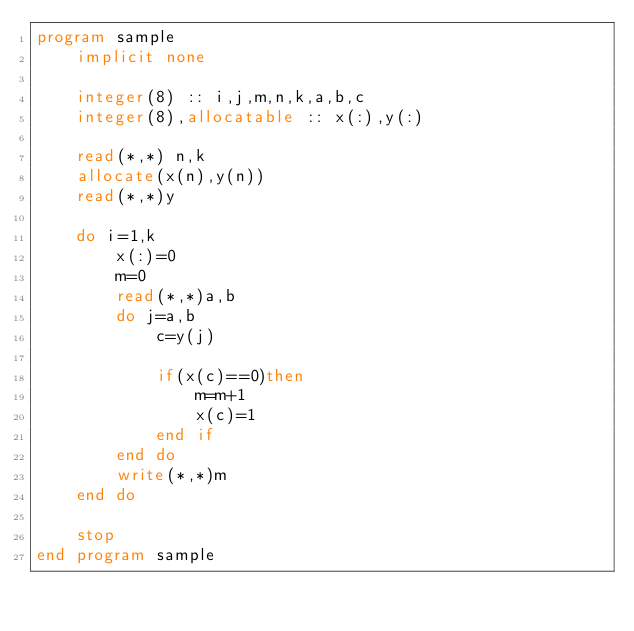Convert code to text. <code><loc_0><loc_0><loc_500><loc_500><_FORTRAN_>program sample
    implicit none
  
    integer(8) :: i,j,m,n,k,a,b,c
    integer(8),allocatable :: x(:),y(:)
  
    read(*,*) n,k
    allocate(x(n),y(n))
    read(*,*)y

    do i=1,k
        x(:)=0
        m=0
        read(*,*)a,b
        do j=a,b
            c=y(j)
            
            if(x(c)==0)then
                m=m+1
                x(c)=1
            end if
        end do
        write(*,*)m
    end do
  
    stop
end program sample
  

</code> 